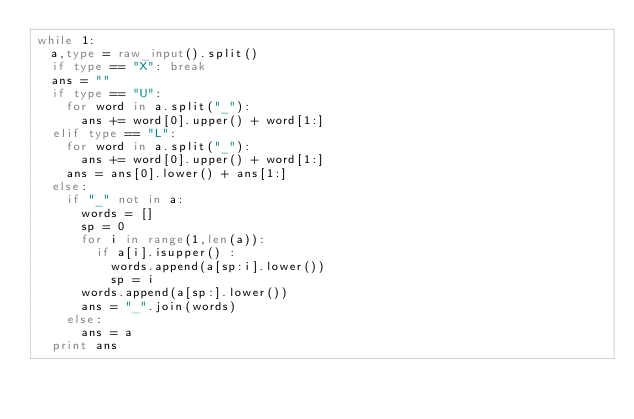<code> <loc_0><loc_0><loc_500><loc_500><_Python_>while 1:
	a,type = raw_input().split()
	if type == "X": break
	ans = ""
	if type == "U":
		for word in a.split("_"):
			ans += word[0].upper() + word[1:]
	elif type == "L":
		for word in a.split("_"):
			ans += word[0].upper() + word[1:]
		ans = ans[0].lower() + ans[1:]
	else:
		if "_" not in a:
			words = []
			sp = 0
			for i in range(1,len(a)):
				if a[i].isupper() :
					words.append(a[sp:i].lower())
					sp = i
			words.append(a[sp:].lower())
			ans = "_".join(words)
		else:
			ans = a
	print ans</code> 